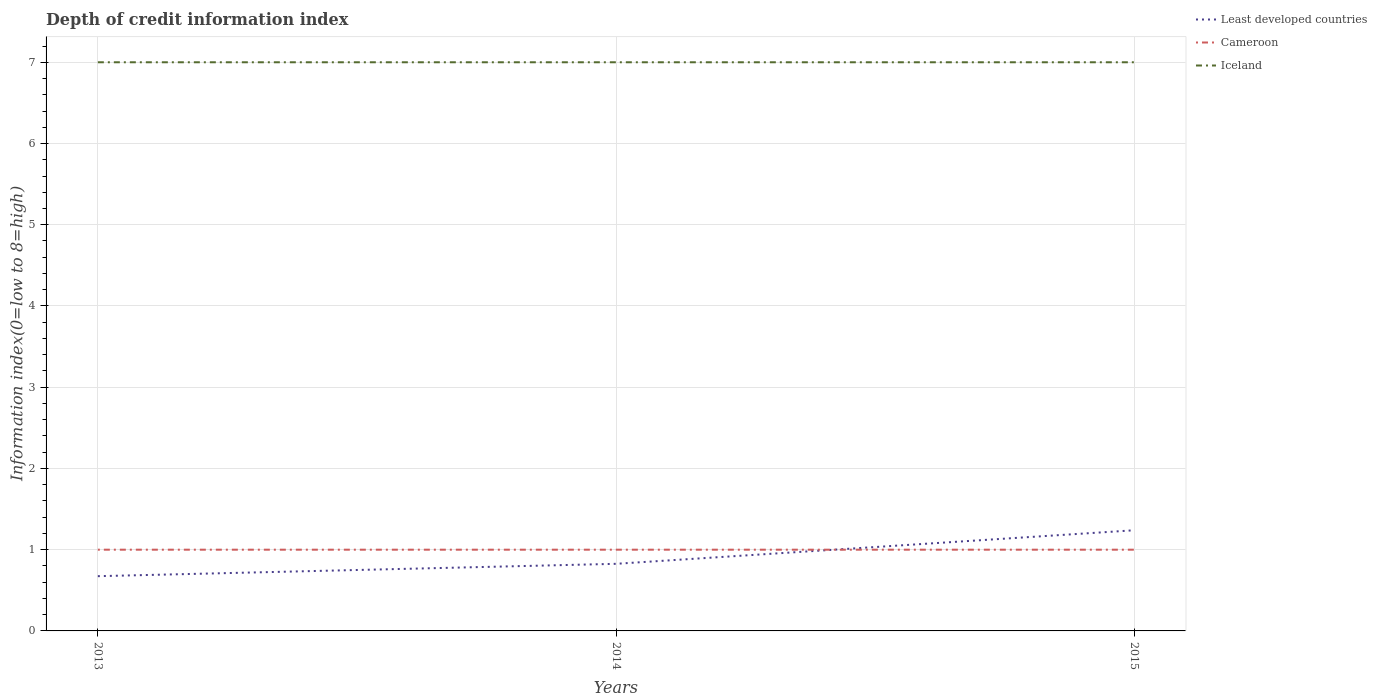How many different coloured lines are there?
Your response must be concise. 3. Across all years, what is the maximum information index in Cameroon?
Your answer should be compact. 1. What is the difference between the highest and the second highest information index in Least developed countries?
Give a very brief answer. 0.57. Is the information index in Iceland strictly greater than the information index in Least developed countries over the years?
Your answer should be very brief. No. How many years are there in the graph?
Your answer should be compact. 3. What is the difference between two consecutive major ticks on the Y-axis?
Offer a very short reply. 1. Does the graph contain any zero values?
Provide a short and direct response. No. Where does the legend appear in the graph?
Your response must be concise. Top right. How many legend labels are there?
Offer a terse response. 3. How are the legend labels stacked?
Offer a very short reply. Vertical. What is the title of the graph?
Ensure brevity in your answer.  Depth of credit information index. Does "Channel Islands" appear as one of the legend labels in the graph?
Offer a very short reply. No. What is the label or title of the X-axis?
Make the answer very short. Years. What is the label or title of the Y-axis?
Offer a terse response. Information index(0=low to 8=high). What is the Information index(0=low to 8=high) of Least developed countries in 2013?
Your response must be concise. 0.67. What is the Information index(0=low to 8=high) of Cameroon in 2013?
Offer a very short reply. 1. What is the Information index(0=low to 8=high) of Iceland in 2013?
Ensure brevity in your answer.  7. What is the Information index(0=low to 8=high) in Least developed countries in 2014?
Your response must be concise. 0.83. What is the Information index(0=low to 8=high) in Least developed countries in 2015?
Keep it short and to the point. 1.24. What is the Information index(0=low to 8=high) of Cameroon in 2015?
Your response must be concise. 1. What is the Information index(0=low to 8=high) of Iceland in 2015?
Your response must be concise. 7. Across all years, what is the maximum Information index(0=low to 8=high) of Least developed countries?
Give a very brief answer. 1.24. Across all years, what is the maximum Information index(0=low to 8=high) of Iceland?
Ensure brevity in your answer.  7. Across all years, what is the minimum Information index(0=low to 8=high) in Least developed countries?
Your answer should be compact. 0.67. Across all years, what is the minimum Information index(0=low to 8=high) in Iceland?
Ensure brevity in your answer.  7. What is the total Information index(0=low to 8=high) of Least developed countries in the graph?
Ensure brevity in your answer.  2.74. What is the total Information index(0=low to 8=high) in Cameroon in the graph?
Your answer should be compact. 3. What is the total Information index(0=low to 8=high) of Iceland in the graph?
Your answer should be compact. 21. What is the difference between the Information index(0=low to 8=high) of Least developed countries in 2013 and that in 2014?
Offer a terse response. -0.15. What is the difference between the Information index(0=low to 8=high) of Cameroon in 2013 and that in 2014?
Keep it short and to the point. 0. What is the difference between the Information index(0=low to 8=high) of Iceland in 2013 and that in 2014?
Ensure brevity in your answer.  0. What is the difference between the Information index(0=low to 8=high) in Least developed countries in 2013 and that in 2015?
Offer a very short reply. -0.57. What is the difference between the Information index(0=low to 8=high) in Cameroon in 2013 and that in 2015?
Your response must be concise. 0. What is the difference between the Information index(0=low to 8=high) of Least developed countries in 2014 and that in 2015?
Provide a succinct answer. -0.41. What is the difference between the Information index(0=low to 8=high) of Cameroon in 2014 and that in 2015?
Offer a terse response. 0. What is the difference between the Information index(0=low to 8=high) of Least developed countries in 2013 and the Information index(0=low to 8=high) of Cameroon in 2014?
Provide a succinct answer. -0.33. What is the difference between the Information index(0=low to 8=high) in Least developed countries in 2013 and the Information index(0=low to 8=high) in Iceland in 2014?
Your response must be concise. -6.33. What is the difference between the Information index(0=low to 8=high) of Cameroon in 2013 and the Information index(0=low to 8=high) of Iceland in 2014?
Offer a very short reply. -6. What is the difference between the Information index(0=low to 8=high) in Least developed countries in 2013 and the Information index(0=low to 8=high) in Cameroon in 2015?
Keep it short and to the point. -0.33. What is the difference between the Information index(0=low to 8=high) of Least developed countries in 2013 and the Information index(0=low to 8=high) of Iceland in 2015?
Your answer should be very brief. -6.33. What is the difference between the Information index(0=low to 8=high) in Least developed countries in 2014 and the Information index(0=low to 8=high) in Cameroon in 2015?
Keep it short and to the point. -0.17. What is the difference between the Information index(0=low to 8=high) in Least developed countries in 2014 and the Information index(0=low to 8=high) in Iceland in 2015?
Your answer should be compact. -6.17. What is the difference between the Information index(0=low to 8=high) in Cameroon in 2014 and the Information index(0=low to 8=high) in Iceland in 2015?
Offer a terse response. -6. What is the average Information index(0=low to 8=high) in Least developed countries per year?
Keep it short and to the point. 0.91. What is the average Information index(0=low to 8=high) in Iceland per year?
Your response must be concise. 7. In the year 2013, what is the difference between the Information index(0=low to 8=high) of Least developed countries and Information index(0=low to 8=high) of Cameroon?
Your answer should be very brief. -0.33. In the year 2013, what is the difference between the Information index(0=low to 8=high) in Least developed countries and Information index(0=low to 8=high) in Iceland?
Your answer should be very brief. -6.33. In the year 2013, what is the difference between the Information index(0=low to 8=high) of Cameroon and Information index(0=low to 8=high) of Iceland?
Provide a succinct answer. -6. In the year 2014, what is the difference between the Information index(0=low to 8=high) in Least developed countries and Information index(0=low to 8=high) in Cameroon?
Offer a terse response. -0.17. In the year 2014, what is the difference between the Information index(0=low to 8=high) of Least developed countries and Information index(0=low to 8=high) of Iceland?
Provide a short and direct response. -6.17. In the year 2014, what is the difference between the Information index(0=low to 8=high) in Cameroon and Information index(0=low to 8=high) in Iceland?
Ensure brevity in your answer.  -6. In the year 2015, what is the difference between the Information index(0=low to 8=high) of Least developed countries and Information index(0=low to 8=high) of Cameroon?
Provide a short and direct response. 0.24. In the year 2015, what is the difference between the Information index(0=low to 8=high) in Least developed countries and Information index(0=low to 8=high) in Iceland?
Your answer should be compact. -5.76. In the year 2015, what is the difference between the Information index(0=low to 8=high) of Cameroon and Information index(0=low to 8=high) of Iceland?
Offer a very short reply. -6. What is the ratio of the Information index(0=low to 8=high) in Least developed countries in 2013 to that in 2014?
Offer a terse response. 0.82. What is the ratio of the Information index(0=low to 8=high) in Cameroon in 2013 to that in 2014?
Your response must be concise. 1. What is the ratio of the Information index(0=low to 8=high) of Least developed countries in 2013 to that in 2015?
Offer a terse response. 0.54. What is the ratio of the Information index(0=low to 8=high) of Iceland in 2014 to that in 2015?
Offer a terse response. 1. What is the difference between the highest and the second highest Information index(0=low to 8=high) of Least developed countries?
Your answer should be compact. 0.41. What is the difference between the highest and the second highest Information index(0=low to 8=high) of Cameroon?
Make the answer very short. 0. What is the difference between the highest and the lowest Information index(0=low to 8=high) in Least developed countries?
Make the answer very short. 0.57. What is the difference between the highest and the lowest Information index(0=low to 8=high) of Cameroon?
Provide a short and direct response. 0. 